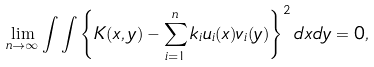<formula> <loc_0><loc_0><loc_500><loc_500>\lim _ { n \rightarrow \infty } \int \int \left \{ K ( x , y ) - \sum _ { i = 1 } ^ { n } k _ { i } u _ { i } ( x ) v _ { i } ( y ) \right \} ^ { 2 } d x d y = 0 ,</formula> 